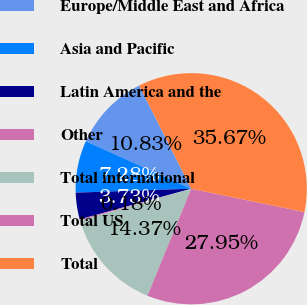Convert chart to OTSL. <chart><loc_0><loc_0><loc_500><loc_500><pie_chart><fcel>Europe/Middle East and Africa<fcel>Asia and Pacific<fcel>Latin America and the<fcel>Other<fcel>Total international<fcel>Total US<fcel>Total<nl><fcel>10.83%<fcel>7.28%<fcel>3.73%<fcel>0.18%<fcel>14.37%<fcel>27.95%<fcel>35.67%<nl></chart> 